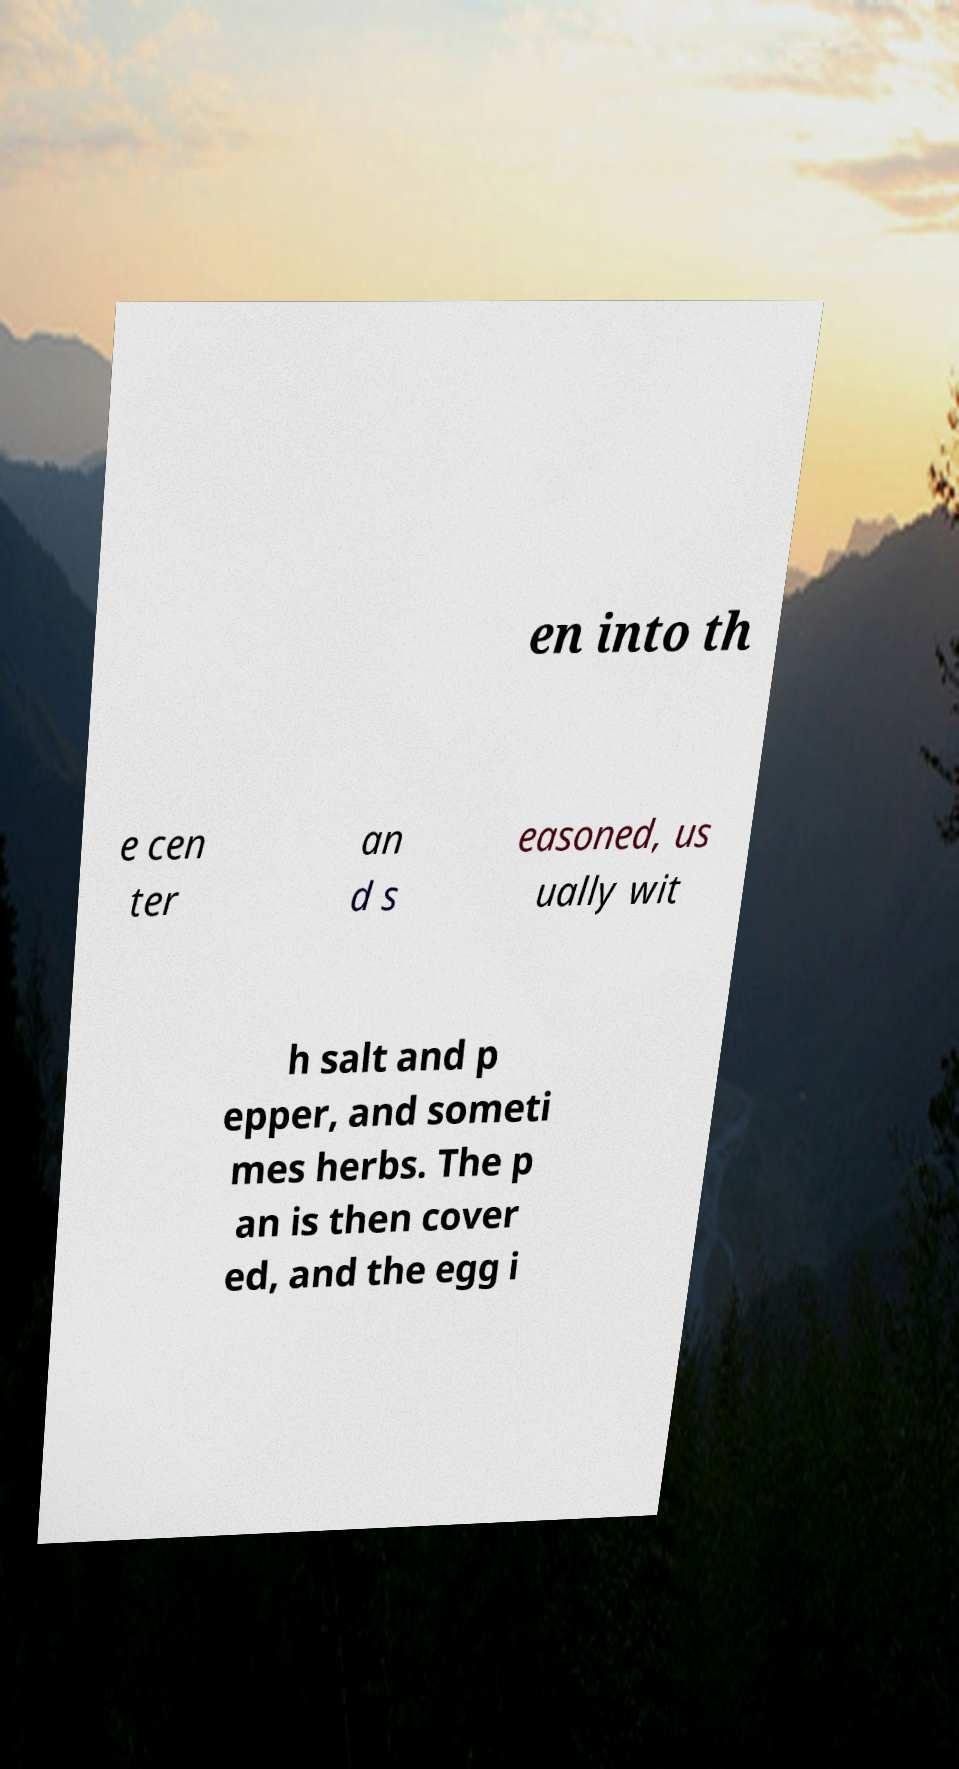Please identify and transcribe the text found in this image. en into th e cen ter an d s easoned, us ually wit h salt and p epper, and someti mes herbs. The p an is then cover ed, and the egg i 